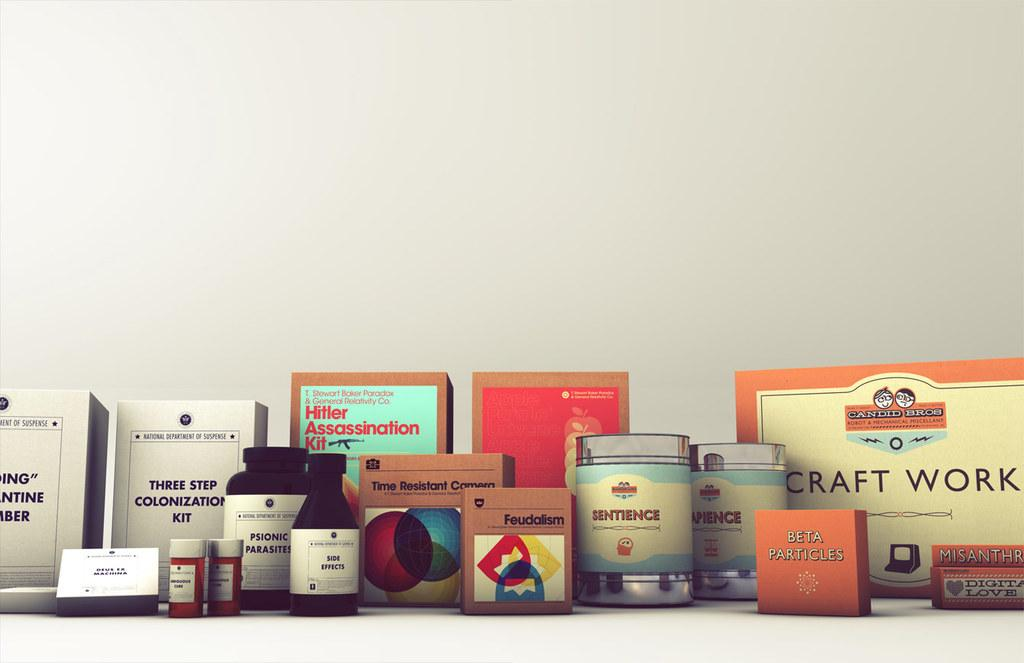<image>
Relay a brief, clear account of the picture shown. several jars and boxes on a table including Digital Love 